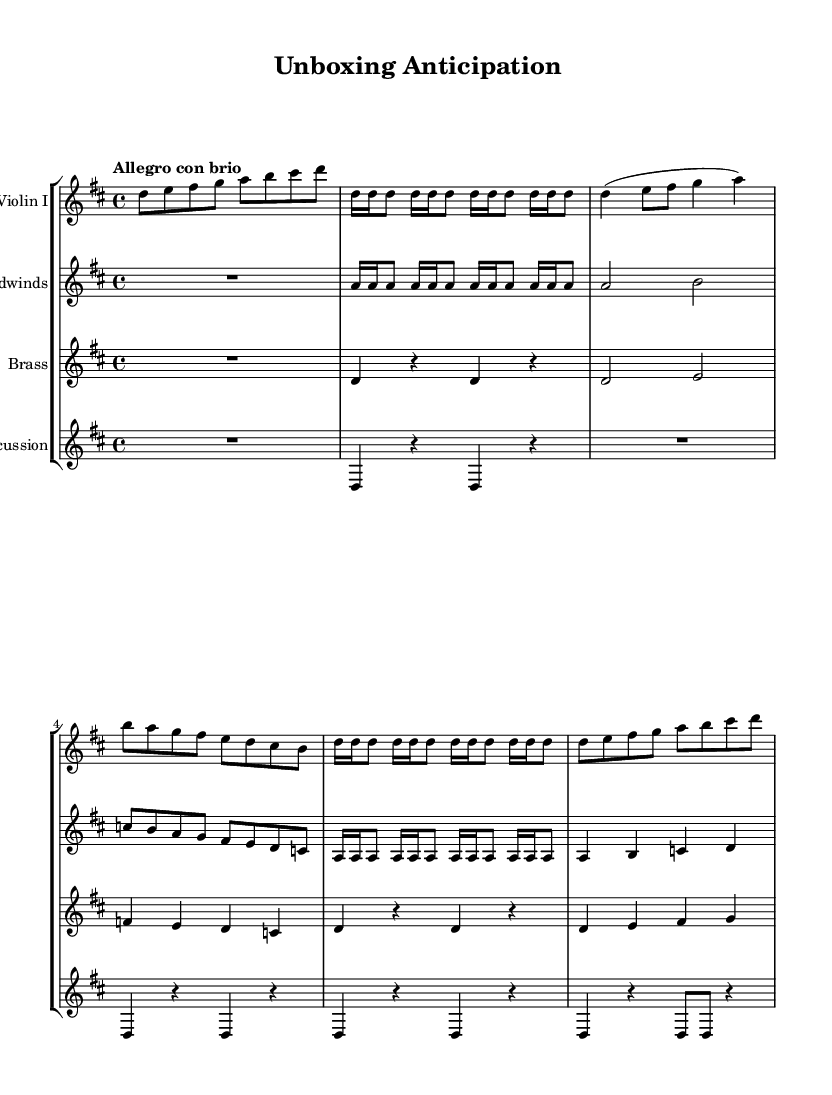What is the key signature of this music? The piece is in D major, which has two sharps, F sharp and C sharp. This can be determined by examining the key signature noted at the beginning of the score.
Answer: D major What is the time signature of the music? The time signature shown at the beginning of the score is 4/4, indicating four beats in each measure and a quarter note receives one beat. This can be seen in the time signature marking located next to the key signature.
Answer: 4/4 What is the tempo marking for the piece? The tempo marking indicates "Allegro con brio," which suggests a fast and lively pace. This is found in the tempo indication at the beginning of the score.
Answer: Allegro con brio How many themes are present in the music? There are two distinct themes identified in the score: Theme A and Theme B. Each theme is introduced, developed, and recapitulated throughout the piece, as indicated in the structure of the sections labeled in the music.
Answer: Two What instrument plays the introduction and theme sections? The Violin I plays the introduction and both theme sections. This can be identified as it is the first staff listed and contains the corresponding notes for these sections.
Answer: Violin I What type of musical piece is represented in this score? This score represents a symphonic work, specifically structured to convey emotions through orchestral arrangements with multiple instrumental parts. This classification can be inferred from the complexity and orchestral format of the score.
Answer: Symphony 